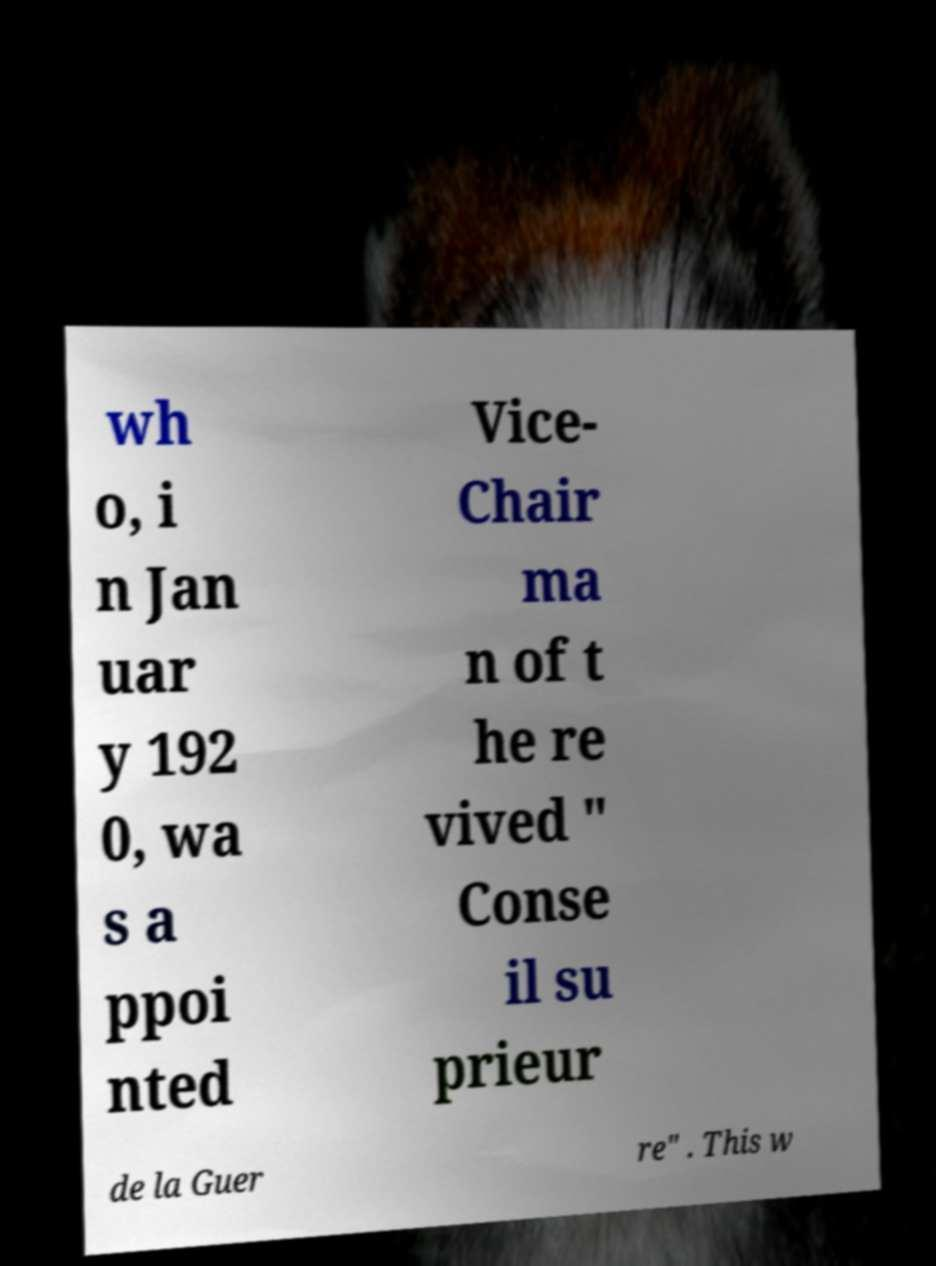There's text embedded in this image that I need extracted. Can you transcribe it verbatim? wh o, i n Jan uar y 192 0, wa s a ppoi nted Vice- Chair ma n of t he re vived " Conse il su prieur de la Guer re" . This w 